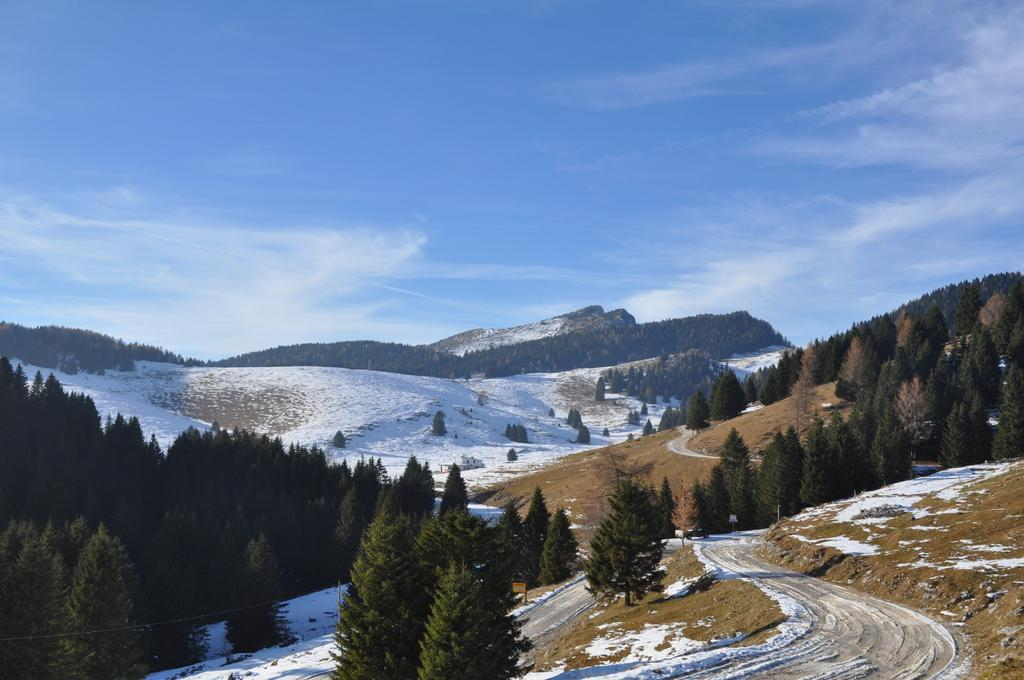What is visible at the bottom of the image? The ground is visible in the image. What is the condition of the ground in the image? The ground is covered with snow. What type of vegetation can be seen in the image? There are trees in the image. What is visible in the background of the image? The sky is visible in the background of the image. What type of hat is the snow wearing in the image? There is no hat present in the image, as snow does not wear hats. 